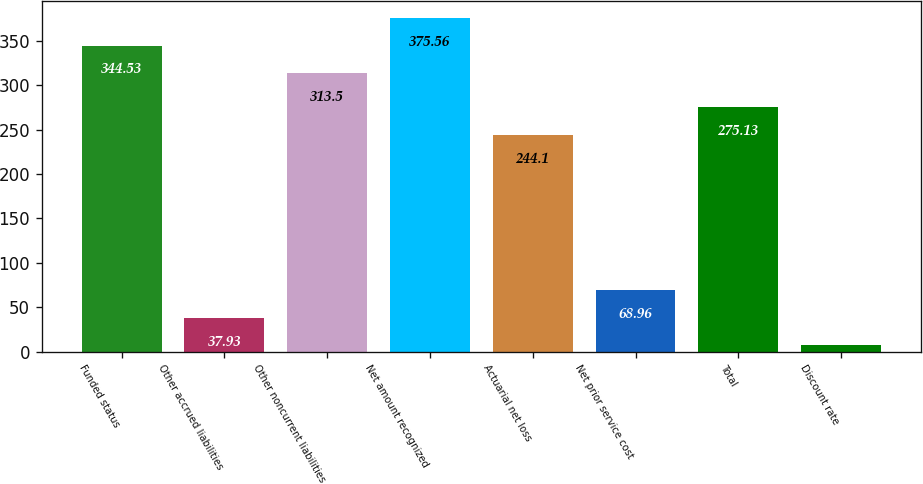Convert chart. <chart><loc_0><loc_0><loc_500><loc_500><bar_chart><fcel>Funded status<fcel>Other accrued liabilities<fcel>Other noncurrent liabilities<fcel>Net amount recognized<fcel>Actuarial net loss<fcel>Net prior service cost<fcel>Total<fcel>Discount rate<nl><fcel>344.53<fcel>37.93<fcel>313.5<fcel>375.56<fcel>244.1<fcel>68.96<fcel>275.13<fcel>6.9<nl></chart> 